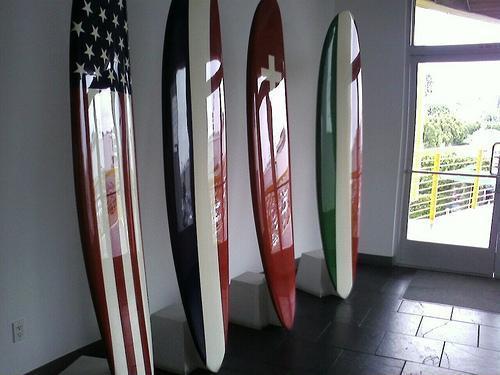How many boards are there?
Give a very brief answer. 4. How many doors are there?
Give a very brief answer. 1. How many surfboards are stored?
Give a very brief answer. 4. How many surfboards are there?
Give a very brief answer. 4. How many boards are there?
Give a very brief answer. 4. How many sheep are there?
Give a very brief answer. 0. 